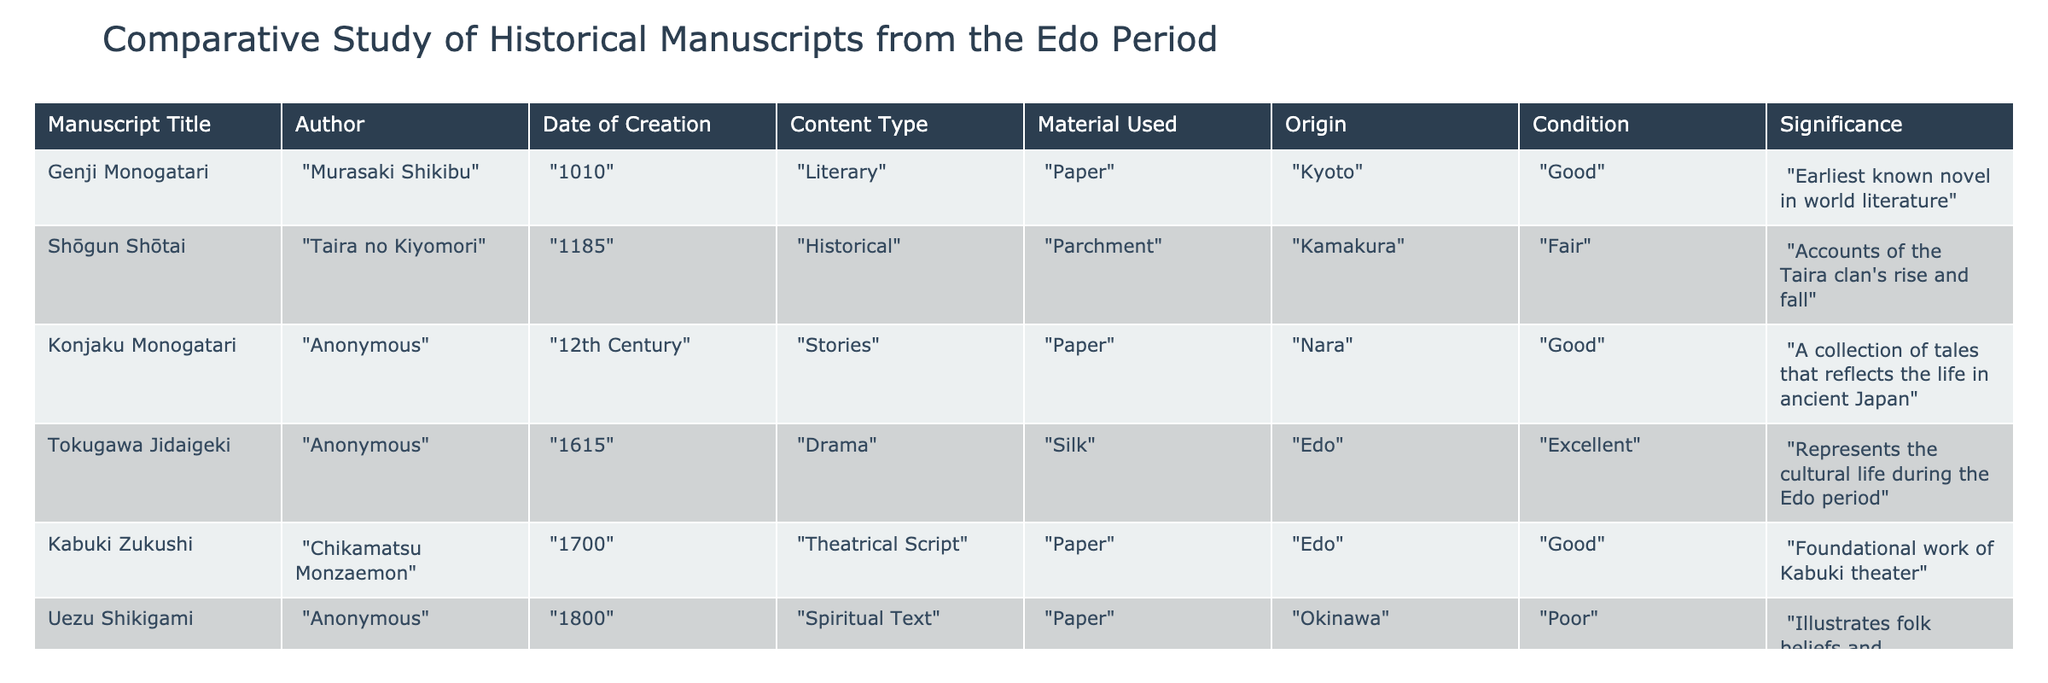What is the title of the earliest known novel in world literature? The table shows that "Genji Monogatari" is listed as the earliest known novel in world literature.
Answer: Genji Monogatari Which manuscript uses silk as its material? Looking at the "Material Used" column, "Tokugawa Jidaigeki" is noted as using silk.
Answer: Tokugawa Jidaigeki How many manuscripts are listed in the table from the Edo period? The table contains six manuscripts, and checking the "Date of Creation" column, the only manuscript from the Edo period is "Tokugawa Jidaigeki" and "Kabuki Zukushi". Thus, there are two manuscripts from the Edo period.
Answer: 2 What is the condition of the manuscript "Uezu Shikigami"? The table indicates that "Uezu Shikigami" is categorized under the "Condition" column as "Poor".
Answer: Poor Is "Kabuki Zukushi" a foundational work of Kabuki theater? According to the "Significance" column in the table, "Kabuki Zukushi" is indeed described as a foundational work of Kabuki theater.
Answer: Yes Which manuscript has the origin labeled as "Okinawa"? From the "Origin" column, we can see that "Uezu Shikigami" is the manuscript that has Okinawa as its origin.
Answer: Uezu Shikigami Calculate the number of manuscripts in "Good" condition. By examining the "Condition" column, there are four manuscripts labeled as "Good" (Genji Monogatari, Konjaku Monogatari, Tokugawa Jidaigeki, Kabuki Zukushi). Adding these gives a total of four manuscripts in good condition: 4.
Answer: 4 Do any manuscripts date back to before the 12th century? Check the "Date of Creation" column to find that "Genji Monogatari" dates to 1010, which is indeed before the 12th century. Therefore, the answer is affirmative.
Answer: Yes Which manuscript, authored by an anonymous writer, talks about spiritual beliefs? "Uezu Shikigami" is listed as authored by an anonymous writer and is categorized under "Spiritual Text", indicating it discusses spiritual beliefs.
Answer: Uezu Shikigami 